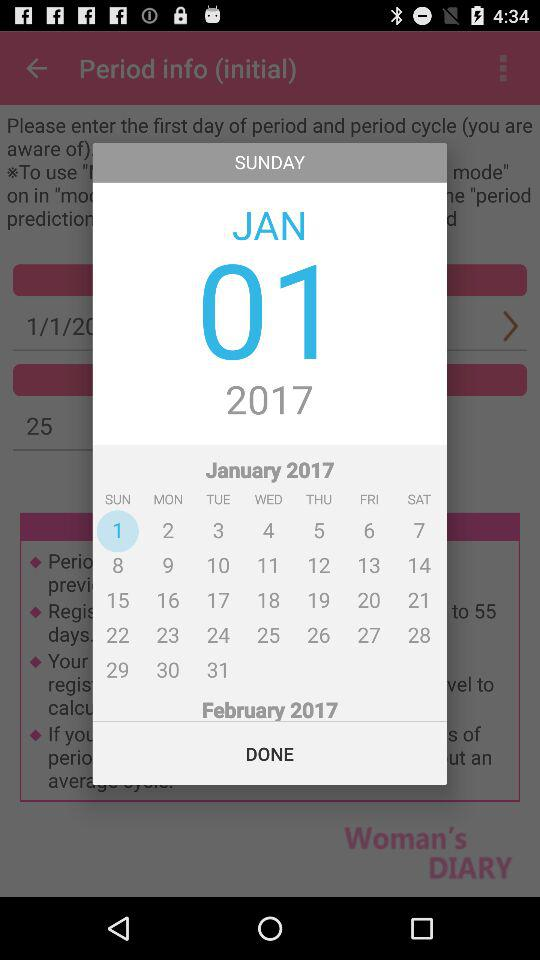What is the year? The year is 2017. 